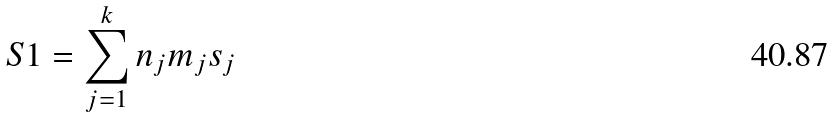Convert formula to latex. <formula><loc_0><loc_0><loc_500><loc_500>S 1 = \sum _ { j = 1 } ^ { k } n _ { j } m _ { j } s _ { j }</formula> 